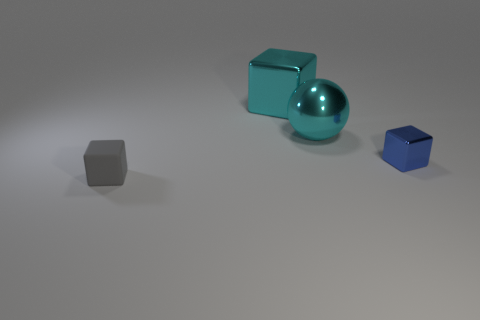Subtract all small blocks. How many blocks are left? 1 Add 3 small rubber objects. How many objects exist? 7 Subtract all spheres. How many objects are left? 3 Add 3 cyan metallic balls. How many cyan metallic balls are left? 4 Add 3 large blocks. How many large blocks exist? 4 Subtract 0 yellow cylinders. How many objects are left? 4 Subtract all metallic things. Subtract all tiny gray things. How many objects are left? 0 